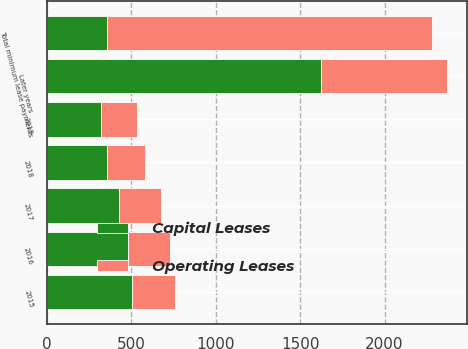Convert chart. <chart><loc_0><loc_0><loc_500><loc_500><stacked_bar_chart><ecel><fcel>2015<fcel>2016<fcel>2017<fcel>2018<fcel>2019<fcel>Later years<fcel>Total minimum lease payments<nl><fcel>Capital Leases<fcel>508<fcel>484<fcel>429<fcel>356<fcel>323<fcel>1625<fcel>356<nl><fcel>Operating Leases<fcel>253<fcel>249<fcel>246<fcel>224<fcel>210<fcel>745<fcel>1927<nl></chart> 